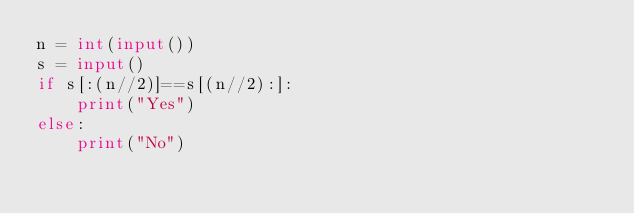<code> <loc_0><loc_0><loc_500><loc_500><_Python_>n = int(input())
s = input()
if s[:(n//2)]==s[(n//2):]:
    print("Yes")
else:
    print("No")</code> 